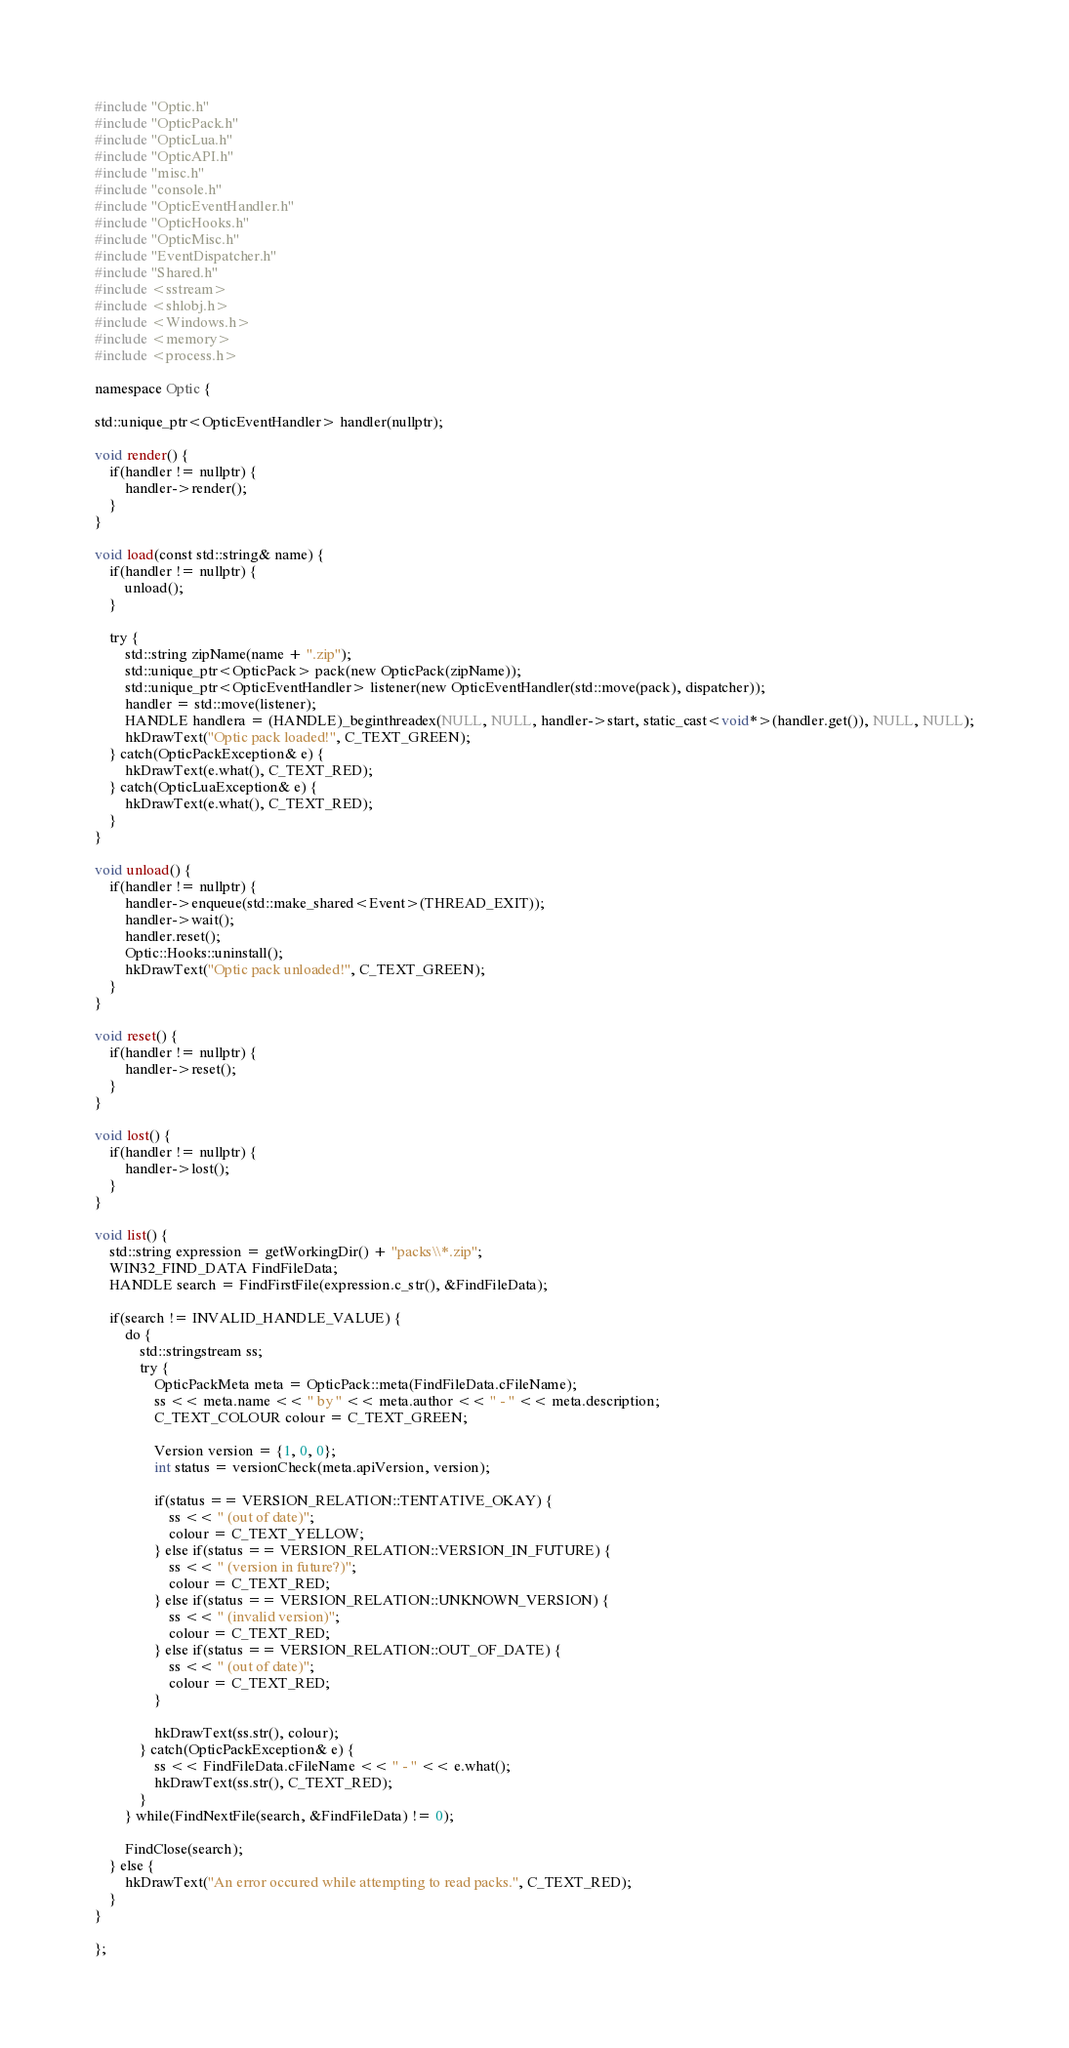Convert code to text. <code><loc_0><loc_0><loc_500><loc_500><_C++_>#include "Optic.h"
#include "OpticPack.h"
#include "OpticLua.h"
#include "OpticAPI.h"
#include "misc.h"
#include "console.h"
#include "OpticEventHandler.h"
#include "OpticHooks.h"
#include "OpticMisc.h"
#include "EventDispatcher.h"
#include "Shared.h"
#include <sstream>
#include <shlobj.h>
#include <Windows.h>
#include <memory>
#include <process.h>

namespace Optic {

std::unique_ptr<OpticEventHandler> handler(nullptr);

void render() {
	if(handler != nullptr) {
		handler->render();
	}
}

void load(const std::string& name) {
	if(handler != nullptr) {
		unload();
	}

	try {
		std::string zipName(name + ".zip");
		std::unique_ptr<OpticPack> pack(new OpticPack(zipName));
		std::unique_ptr<OpticEventHandler> listener(new OpticEventHandler(std::move(pack), dispatcher));
		handler = std::move(listener);
		HANDLE handlera = (HANDLE)_beginthreadex(NULL, NULL, handler->start, static_cast<void*>(handler.get()), NULL, NULL);
		hkDrawText("Optic pack loaded!", C_TEXT_GREEN);
	} catch(OpticPackException& e) {
		hkDrawText(e.what(), C_TEXT_RED);
	} catch(OpticLuaException& e) {
		hkDrawText(e.what(), C_TEXT_RED);
	}
}

void unload() {
	if(handler != nullptr) {
		handler->enqueue(std::make_shared<Event>(THREAD_EXIT));
		handler->wait();
		handler.reset();
		Optic::Hooks::uninstall();
		hkDrawText("Optic pack unloaded!", C_TEXT_GREEN);
	}
}

void reset() {
	if(handler != nullptr) {
		handler->reset();
	}
}

void lost() {
	if(handler != nullptr) {
		handler->lost();
	}
}

void list() {
	std::string expression = getWorkingDir() + "packs\\*.zip";
	WIN32_FIND_DATA FindFileData;
	HANDLE search = FindFirstFile(expression.c_str(), &FindFileData);

	if(search != INVALID_HANDLE_VALUE) {
		do {
			std::stringstream ss;
			try {
				OpticPackMeta meta = OpticPack::meta(FindFileData.cFileName);
				ss << meta.name << " by " << meta.author << " - " << meta.description;
				C_TEXT_COLOUR colour = C_TEXT_GREEN;

				Version version = {1, 0, 0};
				int status = versionCheck(meta.apiVersion, version);

				if(status == VERSION_RELATION::TENTATIVE_OKAY) {
					ss << " (out of date)";
					colour = C_TEXT_YELLOW;
				} else if(status == VERSION_RELATION::VERSION_IN_FUTURE) {
					ss << " (version in future?)";
					colour = C_TEXT_RED;
				} else if(status == VERSION_RELATION::UNKNOWN_VERSION) {
					ss << " (invalid version)";
					colour = C_TEXT_RED;
				} else if(status == VERSION_RELATION::OUT_OF_DATE) {
					ss << " (out of date)";
					colour = C_TEXT_RED;
				}
				
				hkDrawText(ss.str(), colour);
			} catch(OpticPackException& e) {
				ss << FindFileData.cFileName << " - " << e.what();
				hkDrawText(ss.str(), C_TEXT_RED);
			}
		} while(FindNextFile(search, &FindFileData) != 0);

		FindClose(search);
	} else {
		hkDrawText("An error occured while attempting to read packs.", C_TEXT_RED);
	}
}

};</code> 